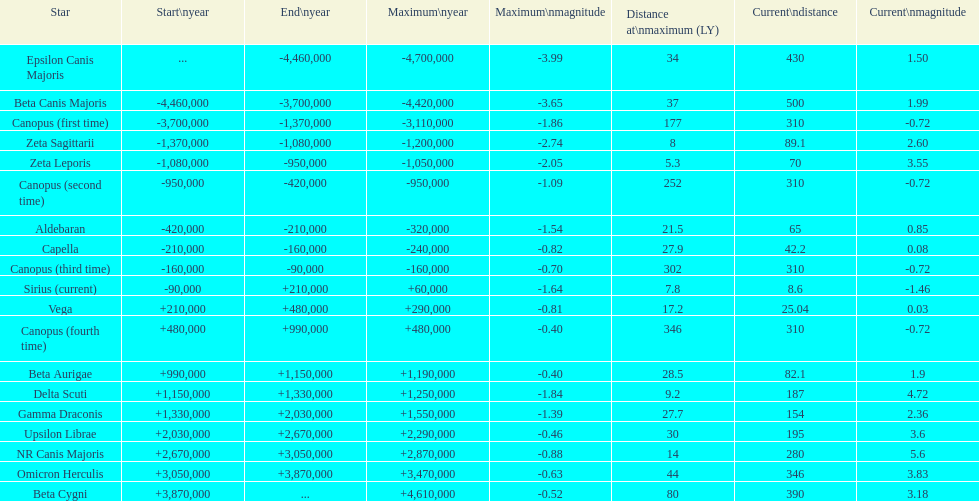Which star possesses the maximum distance at its highest point? Canopus (fourth time). 